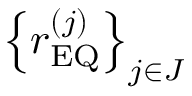<formula> <loc_0><loc_0><loc_500><loc_500>\left \{ r _ { E Q } ^ { \left ( j \right ) } \right \} _ { j \in J }</formula> 